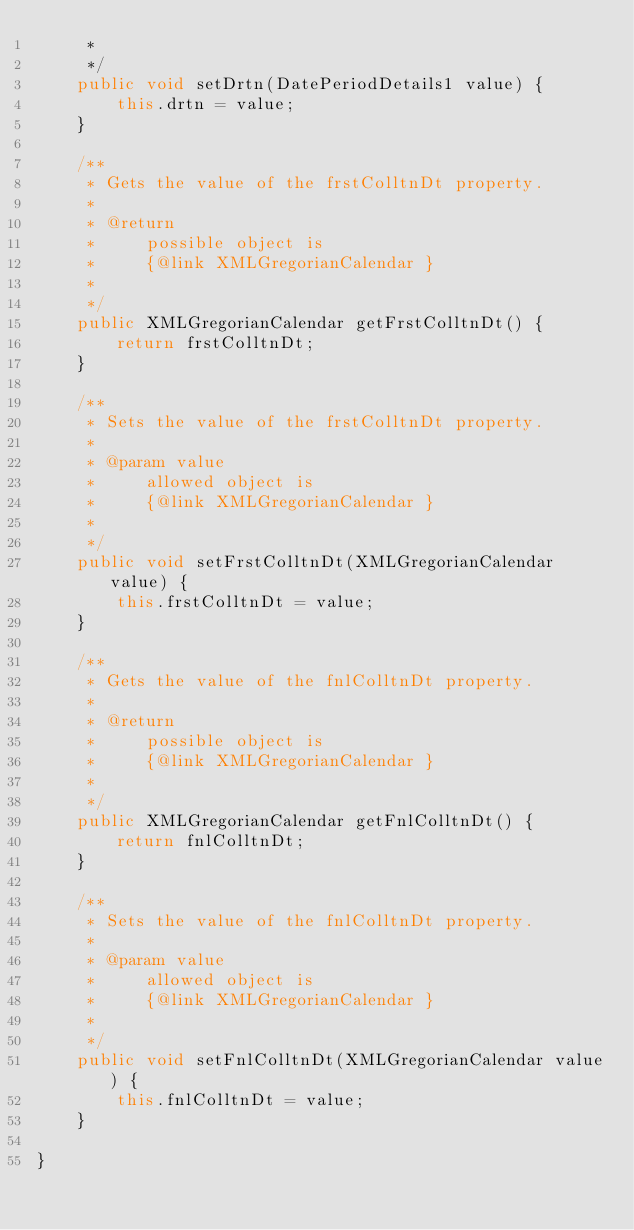Convert code to text. <code><loc_0><loc_0><loc_500><loc_500><_Java_>     *     
     */
    public void setDrtn(DatePeriodDetails1 value) {
        this.drtn = value;
    }

    /**
     * Gets the value of the frstColltnDt property.
     * 
     * @return
     *     possible object is
     *     {@link XMLGregorianCalendar }
     *     
     */
    public XMLGregorianCalendar getFrstColltnDt() {
        return frstColltnDt;
    }

    /**
     * Sets the value of the frstColltnDt property.
     * 
     * @param value
     *     allowed object is
     *     {@link XMLGregorianCalendar }
     *     
     */
    public void setFrstColltnDt(XMLGregorianCalendar value) {
        this.frstColltnDt = value;
    }

    /**
     * Gets the value of the fnlColltnDt property.
     * 
     * @return
     *     possible object is
     *     {@link XMLGregorianCalendar }
     *     
     */
    public XMLGregorianCalendar getFnlColltnDt() {
        return fnlColltnDt;
    }

    /**
     * Sets the value of the fnlColltnDt property.
     * 
     * @param value
     *     allowed object is
     *     {@link XMLGregorianCalendar }
     *     
     */
    public void setFnlColltnDt(XMLGregorianCalendar value) {
        this.fnlColltnDt = value;
    }

}
</code> 